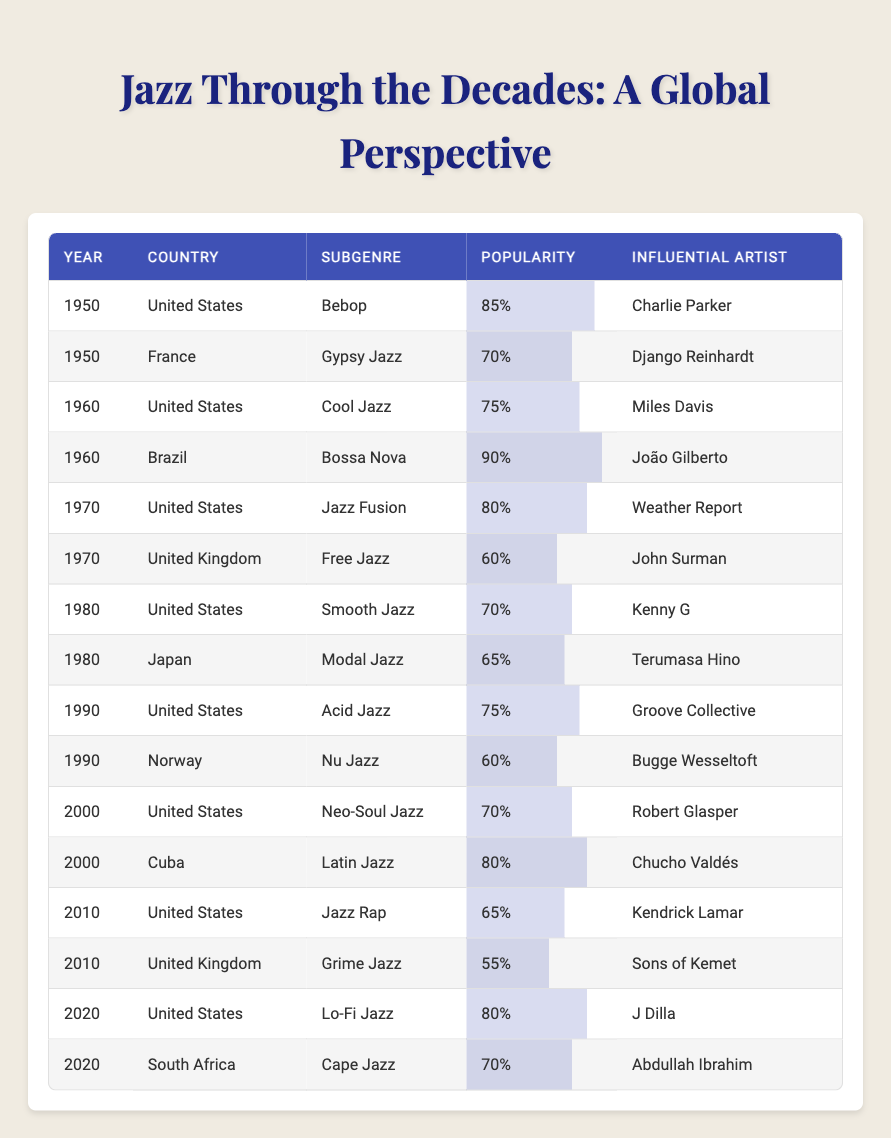What was the most popular jazz subgenre in the United States in 1960? Referring to the table, in 1960, the popularity of the subgenres in the United States is listed. The relevant subgenre for that year is Cool Jazz with a popularity score of 75.
Answer: 75 Which jazz subgenre had the highest popularity in Brazil? The table indicates that in 1960, Brazil's Bossa Nova had the highest popularity score of 90. This is the only entry for Brazil, thus it’s the highest.
Answer: 90 Was Smooth Jazz more popular than Modal Jazz in 1980? In 1980, Smooth Jazz had a popularity score of 70 while Modal Jazz in Japan had a score of 65. Since 70 is greater than 65, Smooth Jazz was indeed more popular.
Answer: Yes What was the average popularity score of jazz subgenres in the United States from 1950 to 2020? To find the average, sum the popularity scores of the entries for the United States: 85 (Bebop) + 75 (Cool Jazz) + 80 (Jazz Fusion) + 70 (Smooth Jazz) + 75 (Acid Jazz) + 70 (Neo-Soul Jazz) + 65 (Jazz Rap) + 80 (Lo-Fi Jazz) = 570. There are 8 entries, so the average is 570/8 = 71.25.
Answer: 71.25 Which influential artist from Cuba had a better popularity score in 2000 compared to the United States? In 2000, Chucho Valdés from Cuba had a popularity score of 80 while Robert Glasper from the United States had a score of 70. Since 80 is greater than 70, Valdés had a better score.
Answer: Yes In which year did Grime Jazz emerge in the United Kingdom, and how popular was it? The table shows that Grime Jazz first appeared in 2010 in the United Kingdom with a popularity score of 55.
Answer: 2010, 55 What was the trend of popularity for jazz genres from 1950 to 2020 in the United States? By reviewing the popularity scores in the table from 1950 (85), 1960 (75), 1970 (80), 1980 (70), 1990 (75), 2000 (70), 2010 (65), to 2020 (80), the scores fluctuate but generally show a downward trend until 2010 and then an increase in 2020.
Answer: Fluctuating with a decrease and then increase How did the popularity of Jazz Fusion in 1970 compare to the highest-ranked subgenre in that year? In 1970, Jazz Fusion in the United States scored 80. The highest score for that year is held by Bossa Nova in Brazil with a score of 90. Therefore, Jazz Fusion scored 10 points lower than the highest.
Answer: 10 points lower 